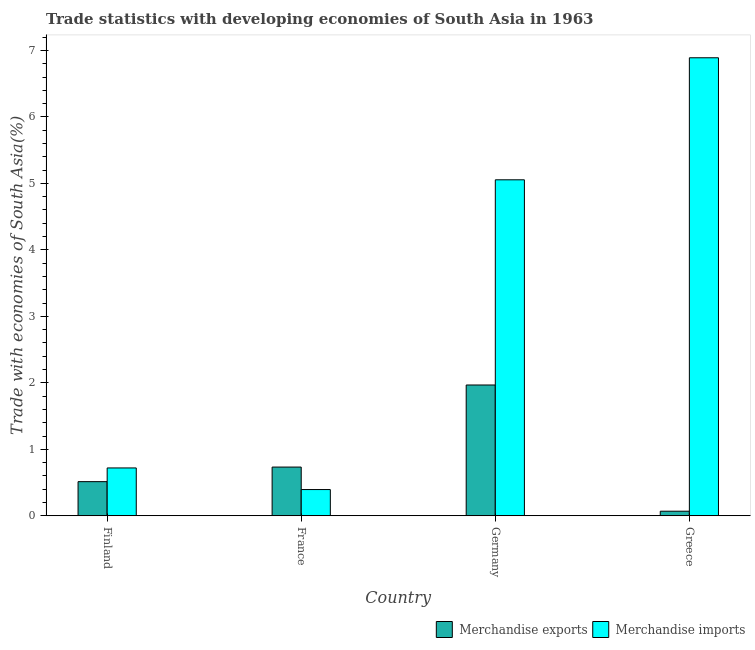Are the number of bars per tick equal to the number of legend labels?
Provide a short and direct response. Yes. How many bars are there on the 2nd tick from the right?
Give a very brief answer. 2. What is the label of the 1st group of bars from the left?
Provide a short and direct response. Finland. In how many cases, is the number of bars for a given country not equal to the number of legend labels?
Provide a succinct answer. 0. What is the merchandise imports in Greece?
Provide a short and direct response. 6.89. Across all countries, what is the maximum merchandise exports?
Make the answer very short. 1.97. Across all countries, what is the minimum merchandise imports?
Make the answer very short. 0.39. In which country was the merchandise imports maximum?
Make the answer very short. Greece. In which country was the merchandise imports minimum?
Offer a very short reply. France. What is the total merchandise exports in the graph?
Your answer should be very brief. 3.28. What is the difference between the merchandise exports in France and that in Germany?
Make the answer very short. -1.23. What is the difference between the merchandise exports in Finland and the merchandise imports in France?
Make the answer very short. 0.12. What is the average merchandise exports per country?
Provide a succinct answer. 0.82. What is the difference between the merchandise imports and merchandise exports in Germany?
Keep it short and to the point. 3.09. In how many countries, is the merchandise imports greater than 4 %?
Give a very brief answer. 2. What is the ratio of the merchandise exports in Finland to that in France?
Provide a succinct answer. 0.7. Is the merchandise imports in Finland less than that in Greece?
Provide a succinct answer. Yes. What is the difference between the highest and the second highest merchandise exports?
Provide a succinct answer. 1.23. What is the difference between the highest and the lowest merchandise exports?
Your response must be concise. 1.9. What does the 1st bar from the left in Finland represents?
Your response must be concise. Merchandise exports. How many bars are there?
Offer a terse response. 8. Does the graph contain any zero values?
Ensure brevity in your answer.  No. How many legend labels are there?
Offer a very short reply. 2. How are the legend labels stacked?
Provide a short and direct response. Horizontal. What is the title of the graph?
Your answer should be very brief. Trade statistics with developing economies of South Asia in 1963. What is the label or title of the X-axis?
Ensure brevity in your answer.  Country. What is the label or title of the Y-axis?
Your answer should be compact. Trade with economies of South Asia(%). What is the Trade with economies of South Asia(%) in Merchandise exports in Finland?
Ensure brevity in your answer.  0.51. What is the Trade with economies of South Asia(%) of Merchandise imports in Finland?
Ensure brevity in your answer.  0.72. What is the Trade with economies of South Asia(%) of Merchandise exports in France?
Your answer should be compact. 0.73. What is the Trade with economies of South Asia(%) in Merchandise imports in France?
Provide a succinct answer. 0.39. What is the Trade with economies of South Asia(%) of Merchandise exports in Germany?
Your answer should be very brief. 1.97. What is the Trade with economies of South Asia(%) of Merchandise imports in Germany?
Your answer should be compact. 5.05. What is the Trade with economies of South Asia(%) of Merchandise exports in Greece?
Ensure brevity in your answer.  0.07. What is the Trade with economies of South Asia(%) in Merchandise imports in Greece?
Keep it short and to the point. 6.89. Across all countries, what is the maximum Trade with economies of South Asia(%) of Merchandise exports?
Your answer should be compact. 1.97. Across all countries, what is the maximum Trade with economies of South Asia(%) in Merchandise imports?
Make the answer very short. 6.89. Across all countries, what is the minimum Trade with economies of South Asia(%) of Merchandise exports?
Offer a very short reply. 0.07. Across all countries, what is the minimum Trade with economies of South Asia(%) in Merchandise imports?
Give a very brief answer. 0.39. What is the total Trade with economies of South Asia(%) in Merchandise exports in the graph?
Give a very brief answer. 3.28. What is the total Trade with economies of South Asia(%) in Merchandise imports in the graph?
Ensure brevity in your answer.  13.06. What is the difference between the Trade with economies of South Asia(%) in Merchandise exports in Finland and that in France?
Offer a terse response. -0.22. What is the difference between the Trade with economies of South Asia(%) of Merchandise imports in Finland and that in France?
Your response must be concise. 0.33. What is the difference between the Trade with economies of South Asia(%) in Merchandise exports in Finland and that in Germany?
Provide a succinct answer. -1.45. What is the difference between the Trade with economies of South Asia(%) of Merchandise imports in Finland and that in Germany?
Your response must be concise. -4.33. What is the difference between the Trade with economies of South Asia(%) of Merchandise exports in Finland and that in Greece?
Your answer should be very brief. 0.44. What is the difference between the Trade with economies of South Asia(%) of Merchandise imports in Finland and that in Greece?
Give a very brief answer. -6.17. What is the difference between the Trade with economies of South Asia(%) of Merchandise exports in France and that in Germany?
Offer a very short reply. -1.23. What is the difference between the Trade with economies of South Asia(%) of Merchandise imports in France and that in Germany?
Your response must be concise. -4.66. What is the difference between the Trade with economies of South Asia(%) in Merchandise exports in France and that in Greece?
Provide a short and direct response. 0.66. What is the difference between the Trade with economies of South Asia(%) of Merchandise imports in France and that in Greece?
Keep it short and to the point. -6.5. What is the difference between the Trade with economies of South Asia(%) in Merchandise exports in Germany and that in Greece?
Provide a short and direct response. 1.9. What is the difference between the Trade with economies of South Asia(%) of Merchandise imports in Germany and that in Greece?
Your answer should be very brief. -1.84. What is the difference between the Trade with economies of South Asia(%) in Merchandise exports in Finland and the Trade with economies of South Asia(%) in Merchandise imports in France?
Give a very brief answer. 0.12. What is the difference between the Trade with economies of South Asia(%) in Merchandise exports in Finland and the Trade with economies of South Asia(%) in Merchandise imports in Germany?
Offer a terse response. -4.54. What is the difference between the Trade with economies of South Asia(%) in Merchandise exports in Finland and the Trade with economies of South Asia(%) in Merchandise imports in Greece?
Your answer should be very brief. -6.38. What is the difference between the Trade with economies of South Asia(%) of Merchandise exports in France and the Trade with economies of South Asia(%) of Merchandise imports in Germany?
Offer a terse response. -4.32. What is the difference between the Trade with economies of South Asia(%) of Merchandise exports in France and the Trade with economies of South Asia(%) of Merchandise imports in Greece?
Your response must be concise. -6.16. What is the difference between the Trade with economies of South Asia(%) in Merchandise exports in Germany and the Trade with economies of South Asia(%) in Merchandise imports in Greece?
Give a very brief answer. -4.92. What is the average Trade with economies of South Asia(%) in Merchandise exports per country?
Your answer should be very brief. 0.82. What is the average Trade with economies of South Asia(%) in Merchandise imports per country?
Provide a succinct answer. 3.26. What is the difference between the Trade with economies of South Asia(%) of Merchandise exports and Trade with economies of South Asia(%) of Merchandise imports in Finland?
Provide a succinct answer. -0.21. What is the difference between the Trade with economies of South Asia(%) of Merchandise exports and Trade with economies of South Asia(%) of Merchandise imports in France?
Keep it short and to the point. 0.34. What is the difference between the Trade with economies of South Asia(%) in Merchandise exports and Trade with economies of South Asia(%) in Merchandise imports in Germany?
Make the answer very short. -3.09. What is the difference between the Trade with economies of South Asia(%) of Merchandise exports and Trade with economies of South Asia(%) of Merchandise imports in Greece?
Your answer should be very brief. -6.82. What is the ratio of the Trade with economies of South Asia(%) of Merchandise exports in Finland to that in France?
Your answer should be very brief. 0.7. What is the ratio of the Trade with economies of South Asia(%) of Merchandise imports in Finland to that in France?
Offer a terse response. 1.82. What is the ratio of the Trade with economies of South Asia(%) in Merchandise exports in Finland to that in Germany?
Offer a terse response. 0.26. What is the ratio of the Trade with economies of South Asia(%) in Merchandise imports in Finland to that in Germany?
Give a very brief answer. 0.14. What is the ratio of the Trade with economies of South Asia(%) of Merchandise exports in Finland to that in Greece?
Your response must be concise. 7.45. What is the ratio of the Trade with economies of South Asia(%) in Merchandise imports in Finland to that in Greece?
Your answer should be compact. 0.1. What is the ratio of the Trade with economies of South Asia(%) in Merchandise exports in France to that in Germany?
Ensure brevity in your answer.  0.37. What is the ratio of the Trade with economies of South Asia(%) in Merchandise imports in France to that in Germany?
Your answer should be very brief. 0.08. What is the ratio of the Trade with economies of South Asia(%) of Merchandise exports in France to that in Greece?
Your answer should be very brief. 10.63. What is the ratio of the Trade with economies of South Asia(%) in Merchandise imports in France to that in Greece?
Offer a very short reply. 0.06. What is the ratio of the Trade with economies of South Asia(%) in Merchandise exports in Germany to that in Greece?
Make the answer very short. 28.55. What is the ratio of the Trade with economies of South Asia(%) of Merchandise imports in Germany to that in Greece?
Make the answer very short. 0.73. What is the difference between the highest and the second highest Trade with economies of South Asia(%) of Merchandise exports?
Your response must be concise. 1.23. What is the difference between the highest and the second highest Trade with economies of South Asia(%) of Merchandise imports?
Keep it short and to the point. 1.84. What is the difference between the highest and the lowest Trade with economies of South Asia(%) in Merchandise exports?
Offer a terse response. 1.9. What is the difference between the highest and the lowest Trade with economies of South Asia(%) in Merchandise imports?
Your response must be concise. 6.5. 